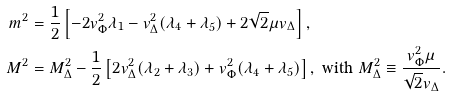Convert formula to latex. <formula><loc_0><loc_0><loc_500><loc_500>m ^ { 2 } & = \frac { 1 } { 2 } \left [ - 2 v _ { \Phi } ^ { 2 } \lambda _ { 1 } - v _ { \Delta } ^ { 2 } ( \lambda _ { 4 } + \lambda _ { 5 } ) + 2 \sqrt { 2 } \mu v _ { \Delta } \right ] , \\ M ^ { 2 } & = M _ { \Delta } ^ { 2 } - \frac { 1 } { 2 } \left [ 2 v _ { \Delta } ^ { 2 } ( \lambda _ { 2 } + \lambda _ { 3 } ) + v _ { \Phi } ^ { 2 } ( \lambda _ { 4 } + \lambda _ { 5 } ) \right ] , \text { with } M _ { \Delta } ^ { 2 } \equiv \frac { v _ { \Phi } ^ { 2 } \mu } { \sqrt { 2 } v _ { \Delta } } .</formula> 